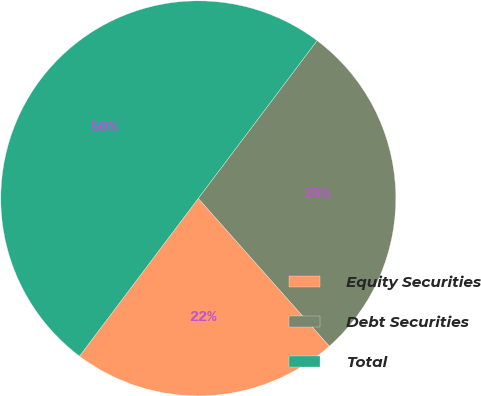Convert chart. <chart><loc_0><loc_0><loc_500><loc_500><pie_chart><fcel>Equity Securities<fcel>Debt Securities<fcel>Total<nl><fcel>21.82%<fcel>28.18%<fcel>50.0%<nl></chart> 